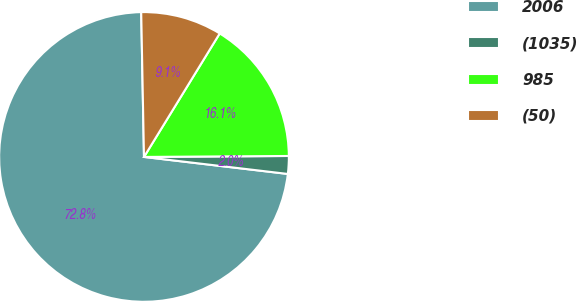Convert chart to OTSL. <chart><loc_0><loc_0><loc_500><loc_500><pie_chart><fcel>2006<fcel>(1035)<fcel>985<fcel>(50)<nl><fcel>72.82%<fcel>1.98%<fcel>16.14%<fcel>9.06%<nl></chart> 